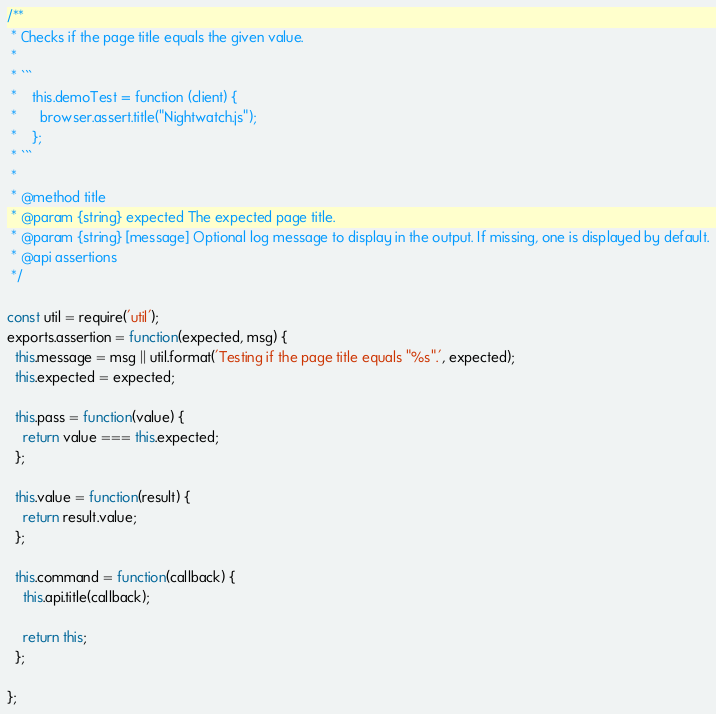<code> <loc_0><loc_0><loc_500><loc_500><_JavaScript_>/**
 * Checks if the page title equals the given value.
 *
 * ```
 *    this.demoTest = function (client) {
 *      browser.assert.title("Nightwatch.js");
 *    };
 * ```
 *
 * @method title
 * @param {string} expected The expected page title.
 * @param {string} [message] Optional log message to display in the output. If missing, one is displayed by default.
 * @api assertions
 */

const util = require('util');
exports.assertion = function(expected, msg) {
  this.message = msg || util.format('Testing if the page title equals "%s".', expected);
  this.expected = expected;

  this.pass = function(value) {
    return value === this.expected;
  };

  this.value = function(result) {
    return result.value;
  };

  this.command = function(callback) {
    this.api.title(callback);

    return this;
  };

};
</code> 